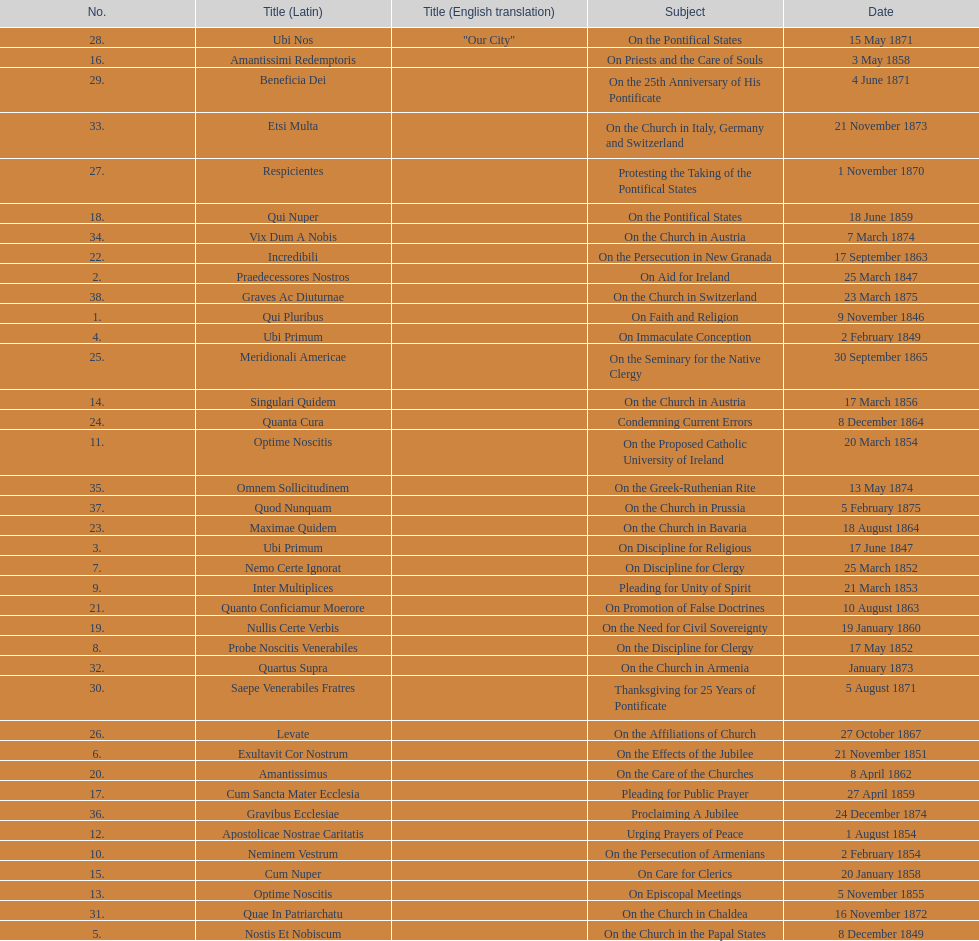What is the previous subject after on the effects of the jubilee? On the Church in the Papal States. 